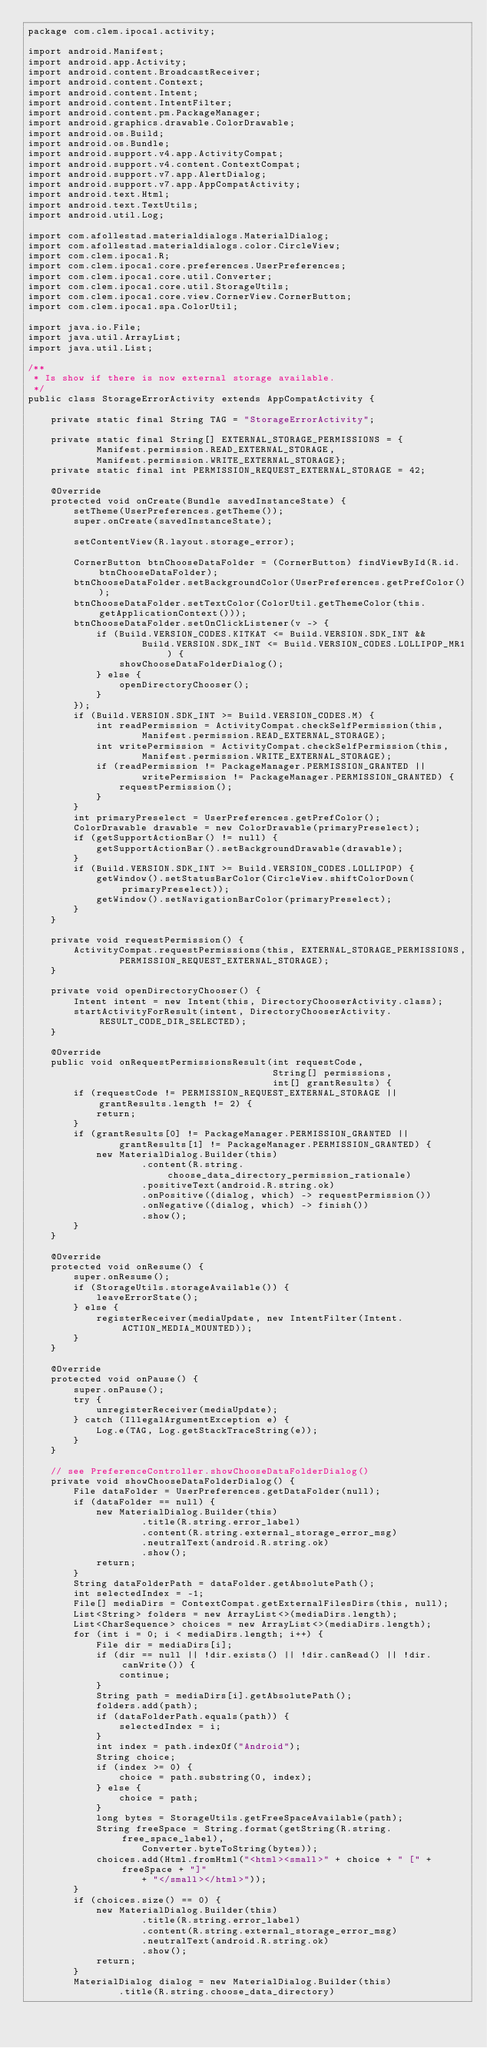<code> <loc_0><loc_0><loc_500><loc_500><_Java_>package com.clem.ipoca1.activity;

import android.Manifest;
import android.app.Activity;
import android.content.BroadcastReceiver;
import android.content.Context;
import android.content.Intent;
import android.content.IntentFilter;
import android.content.pm.PackageManager;
import android.graphics.drawable.ColorDrawable;
import android.os.Build;
import android.os.Bundle;
import android.support.v4.app.ActivityCompat;
import android.support.v4.content.ContextCompat;
import android.support.v7.app.AlertDialog;
import android.support.v7.app.AppCompatActivity;
import android.text.Html;
import android.text.TextUtils;
import android.util.Log;

import com.afollestad.materialdialogs.MaterialDialog;
import com.afollestad.materialdialogs.color.CircleView;
import com.clem.ipoca1.R;
import com.clem.ipoca1.core.preferences.UserPreferences;
import com.clem.ipoca1.core.util.Converter;
import com.clem.ipoca1.core.util.StorageUtils;
import com.clem.ipoca1.core.view.CornerView.CornerButton;
import com.clem.ipoca1.spa.ColorUtil;

import java.io.File;
import java.util.ArrayList;
import java.util.List;

/**
 * Is show if there is now external storage available.
 */
public class StorageErrorActivity extends AppCompatActivity {

    private static final String TAG = "StorageErrorActivity";

    private static final String[] EXTERNAL_STORAGE_PERMISSIONS = {
            Manifest.permission.READ_EXTERNAL_STORAGE,
            Manifest.permission.WRITE_EXTERNAL_STORAGE};
    private static final int PERMISSION_REQUEST_EXTERNAL_STORAGE = 42;

    @Override
    protected void onCreate(Bundle savedInstanceState) {
        setTheme(UserPreferences.getTheme());
        super.onCreate(savedInstanceState);

        setContentView(R.layout.storage_error);

        CornerButton btnChooseDataFolder = (CornerButton) findViewById(R.id.btnChooseDataFolder);
        btnChooseDataFolder.setBackgroundColor(UserPreferences.getPrefColor());
        btnChooseDataFolder.setTextColor(ColorUtil.getThemeColor(this.getApplicationContext()));
        btnChooseDataFolder.setOnClickListener(v -> {
            if (Build.VERSION_CODES.KITKAT <= Build.VERSION.SDK_INT &&
                    Build.VERSION.SDK_INT <= Build.VERSION_CODES.LOLLIPOP_MR1) {
                showChooseDataFolderDialog();
            } else {
                openDirectoryChooser();
            }
        });
        if (Build.VERSION.SDK_INT >= Build.VERSION_CODES.M) {
            int readPermission = ActivityCompat.checkSelfPermission(this,
                    Manifest.permission.READ_EXTERNAL_STORAGE);
            int writePermission = ActivityCompat.checkSelfPermission(this,
                    Manifest.permission.WRITE_EXTERNAL_STORAGE);
            if (readPermission != PackageManager.PERMISSION_GRANTED ||
                    writePermission != PackageManager.PERMISSION_GRANTED) {
                requestPermission();
            }
        }
        int primaryPreselect = UserPreferences.getPrefColor();
        ColorDrawable drawable = new ColorDrawable(primaryPreselect);
        if (getSupportActionBar() != null) {
            getSupportActionBar().setBackgroundDrawable(drawable);
        }
        if (Build.VERSION.SDK_INT >= Build.VERSION_CODES.LOLLIPOP) {
            getWindow().setStatusBarColor(CircleView.shiftColorDown(primaryPreselect));
            getWindow().setNavigationBarColor(primaryPreselect);
        }
    }

    private void requestPermission() {
        ActivityCompat.requestPermissions(this, EXTERNAL_STORAGE_PERMISSIONS,
                PERMISSION_REQUEST_EXTERNAL_STORAGE);
    }

    private void openDirectoryChooser() {
        Intent intent = new Intent(this, DirectoryChooserActivity.class);
        startActivityForResult(intent, DirectoryChooserActivity.RESULT_CODE_DIR_SELECTED);
    }

    @Override
    public void onRequestPermissionsResult(int requestCode,
                                           String[] permissions,
                                           int[] grantResults) {
        if (requestCode != PERMISSION_REQUEST_EXTERNAL_STORAGE || grantResults.length != 2) {
            return;
        }
        if (grantResults[0] != PackageManager.PERMISSION_GRANTED ||
                grantResults[1] != PackageManager.PERMISSION_GRANTED) {
            new MaterialDialog.Builder(this)
                    .content(R.string.choose_data_directory_permission_rationale)
                    .positiveText(android.R.string.ok)
                    .onPositive((dialog, which) -> requestPermission())
                    .onNegative((dialog, which) -> finish())
                    .show();
        }
    }

    @Override
    protected void onResume() {
        super.onResume();
        if (StorageUtils.storageAvailable()) {
            leaveErrorState();
        } else {
            registerReceiver(mediaUpdate, new IntentFilter(Intent.ACTION_MEDIA_MOUNTED));
        }
    }

    @Override
    protected void onPause() {
        super.onPause();
        try {
            unregisterReceiver(mediaUpdate);
        } catch (IllegalArgumentException e) {
            Log.e(TAG, Log.getStackTraceString(e));
        }
    }

    // see PreferenceController.showChooseDataFolderDialog()
    private void showChooseDataFolderDialog() {
        File dataFolder = UserPreferences.getDataFolder(null);
        if (dataFolder == null) {
            new MaterialDialog.Builder(this)
                    .title(R.string.error_label)
                    .content(R.string.external_storage_error_msg)
                    .neutralText(android.R.string.ok)
                    .show();
            return;
        }
        String dataFolderPath = dataFolder.getAbsolutePath();
        int selectedIndex = -1;
        File[] mediaDirs = ContextCompat.getExternalFilesDirs(this, null);
        List<String> folders = new ArrayList<>(mediaDirs.length);
        List<CharSequence> choices = new ArrayList<>(mediaDirs.length);
        for (int i = 0; i < mediaDirs.length; i++) {
            File dir = mediaDirs[i];
            if (dir == null || !dir.exists() || !dir.canRead() || !dir.canWrite()) {
                continue;
            }
            String path = mediaDirs[i].getAbsolutePath();
            folders.add(path);
            if (dataFolderPath.equals(path)) {
                selectedIndex = i;
            }
            int index = path.indexOf("Android");
            String choice;
            if (index >= 0) {
                choice = path.substring(0, index);
            } else {
                choice = path;
            }
            long bytes = StorageUtils.getFreeSpaceAvailable(path);
            String freeSpace = String.format(getString(R.string.free_space_label),
                    Converter.byteToString(bytes));
            choices.add(Html.fromHtml("<html><small>" + choice + " [" + freeSpace + "]"
                    + "</small></html>"));
        }
        if (choices.size() == 0) {
            new MaterialDialog.Builder(this)
                    .title(R.string.error_label)
                    .content(R.string.external_storage_error_msg)
                    .neutralText(android.R.string.ok)
                    .show();
            return;
        }
        MaterialDialog dialog = new MaterialDialog.Builder(this)
                .title(R.string.choose_data_directory)</code> 